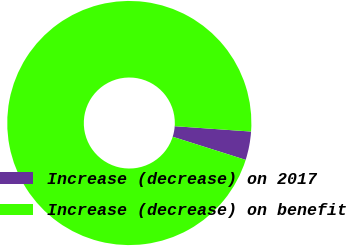Convert chart. <chart><loc_0><loc_0><loc_500><loc_500><pie_chart><fcel>Increase (decrease) on 2017<fcel>Increase (decrease) on benefit<nl><fcel>3.77%<fcel>96.23%<nl></chart> 